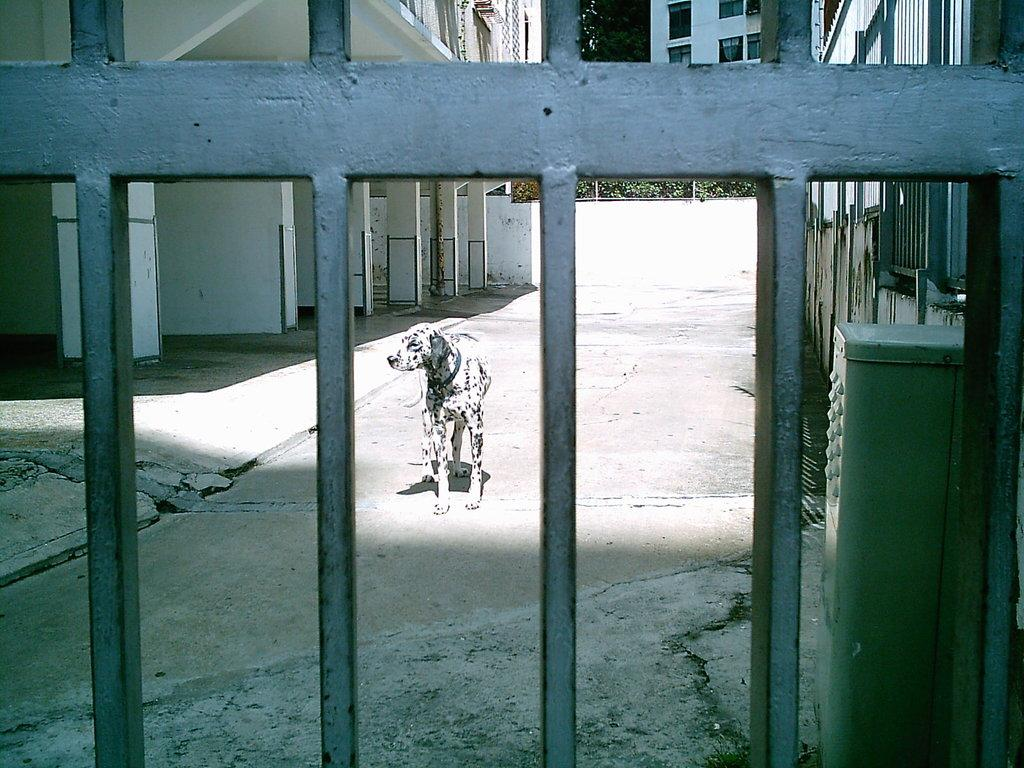What can be seen in the image that is used for cooking? There are grills in the image that are used for cooking. What type of living creature is present on the surface in the image? There is an animal on the surface in the image. What structures can be seen in the background of the image? There are buildings visible in the image. What type of plant is present in the image? There is a tree in the image. What direction is the person walking in the image? There is no person present in the image, so it is not possible to determine the direction they might be walking. 